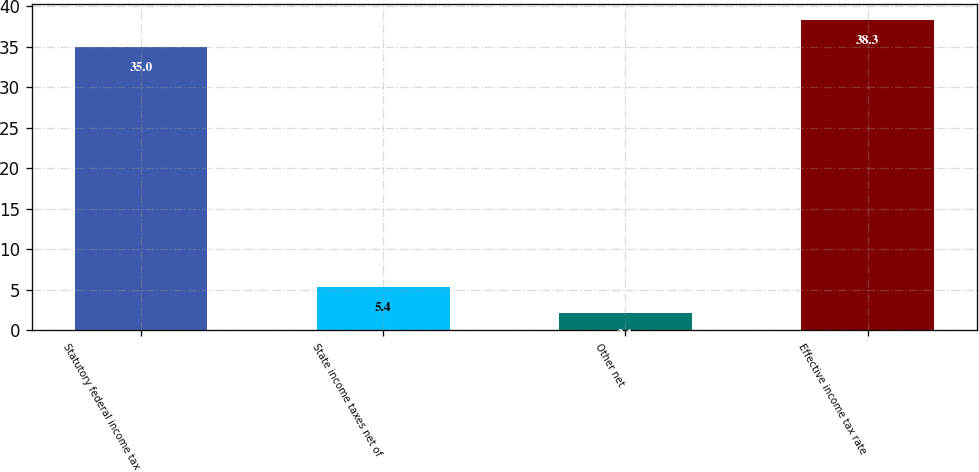Convert chart. <chart><loc_0><loc_0><loc_500><loc_500><bar_chart><fcel>Statutory federal income tax<fcel>State income taxes net of<fcel>Other net<fcel>Effective income tax rate<nl><fcel>35<fcel>5.4<fcel>2.1<fcel>38.3<nl></chart> 